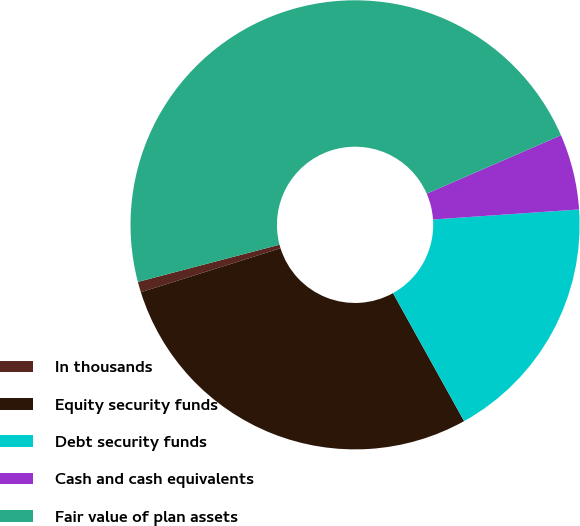Convert chart. <chart><loc_0><loc_0><loc_500><loc_500><pie_chart><fcel>In thousands<fcel>Equity security funds<fcel>Debt security funds<fcel>Cash and cash equivalents<fcel>Fair value of plan assets<nl><fcel>0.76%<fcel>28.22%<fcel>18.02%<fcel>5.44%<fcel>47.56%<nl></chart> 